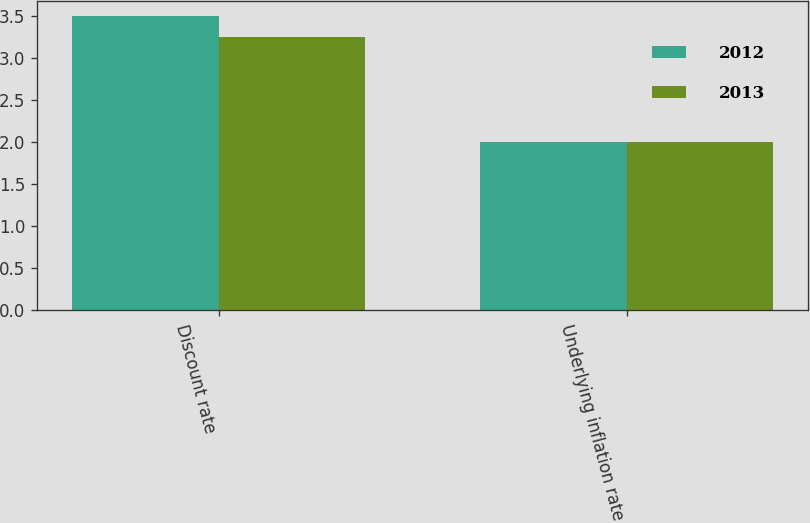Convert chart to OTSL. <chart><loc_0><loc_0><loc_500><loc_500><stacked_bar_chart><ecel><fcel>Discount rate<fcel>Underlying inflation rate<nl><fcel>2012<fcel>3.5<fcel>2<nl><fcel>2013<fcel>3.25<fcel>2<nl></chart> 